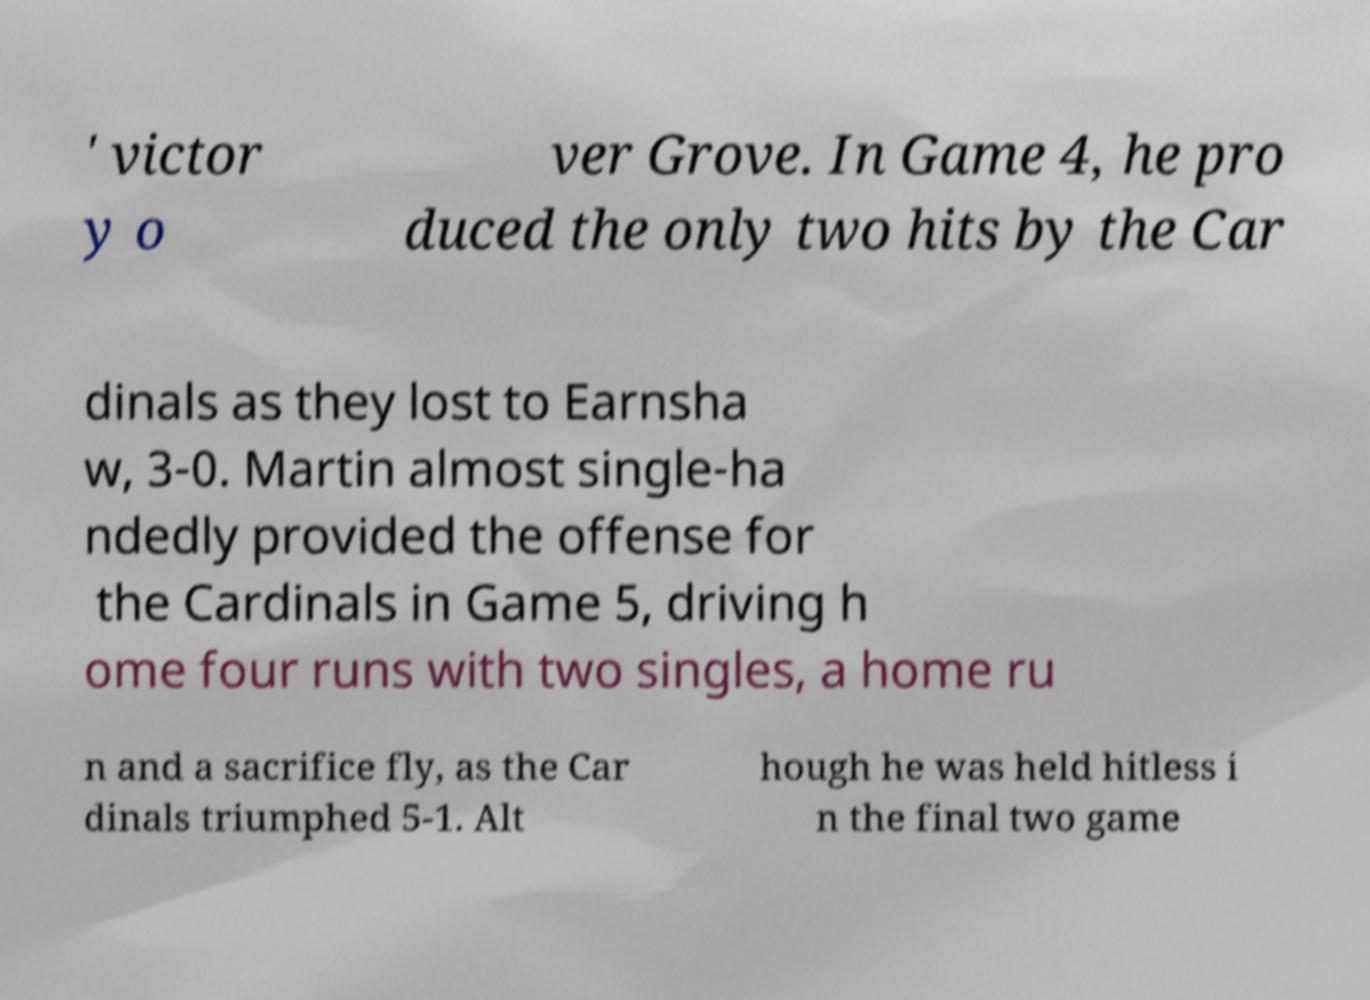What messages or text are displayed in this image? I need them in a readable, typed format. ' victor y o ver Grove. In Game 4, he pro duced the only two hits by the Car dinals as they lost to Earnsha w, 3-0. Martin almost single-ha ndedly provided the offense for the Cardinals in Game 5, driving h ome four runs with two singles, a home ru n and a sacrifice fly, as the Car dinals triumphed 5-1. Alt hough he was held hitless i n the final two game 